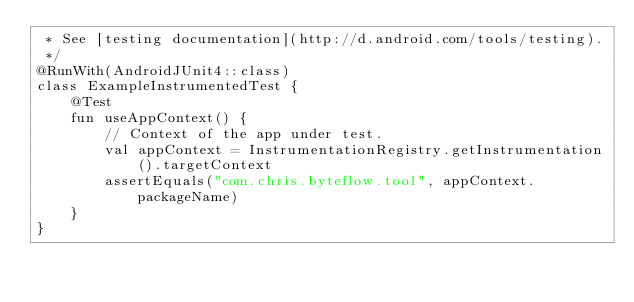<code> <loc_0><loc_0><loc_500><loc_500><_Kotlin_> * See [testing documentation](http://d.android.com/tools/testing).
 */
@RunWith(AndroidJUnit4::class)
class ExampleInstrumentedTest {
    @Test
    fun useAppContext() {
        // Context of the app under test.
        val appContext = InstrumentationRegistry.getInstrumentation().targetContext
        assertEquals("com.chris.byteflow.tool", appContext.packageName)
    }
}</code> 